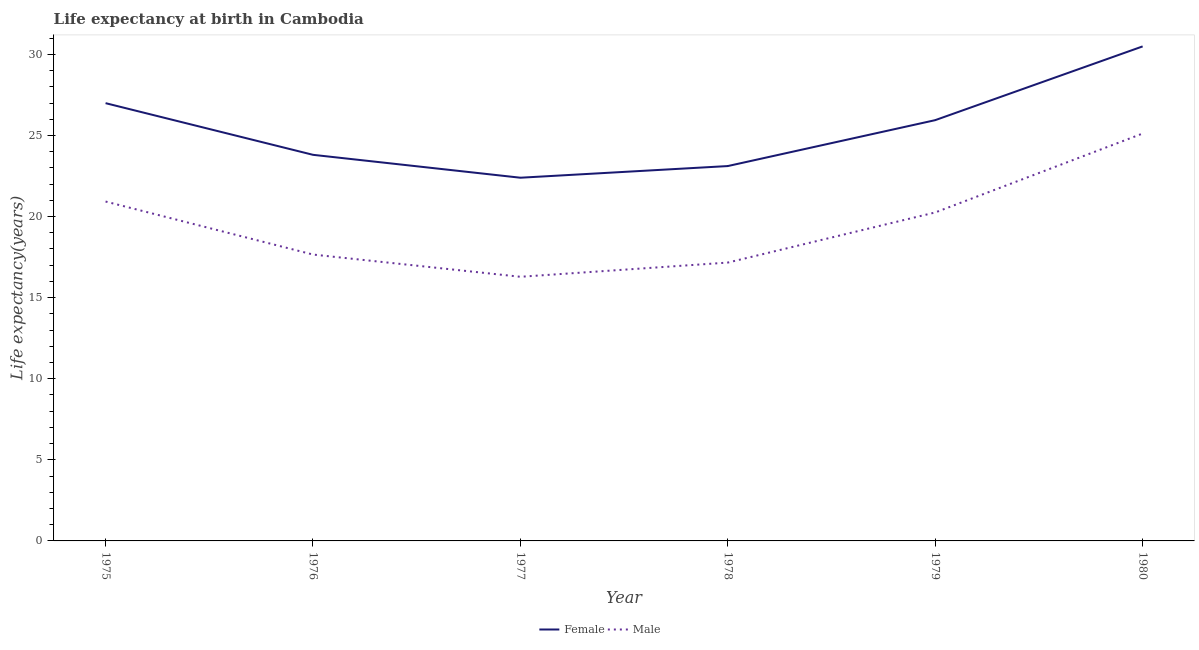What is the life expectancy(male) in 1980?
Provide a short and direct response. 25.12. Across all years, what is the maximum life expectancy(female)?
Offer a terse response. 30.49. Across all years, what is the minimum life expectancy(female)?
Provide a short and direct response. 22.39. In which year was the life expectancy(female) maximum?
Make the answer very short. 1980. In which year was the life expectancy(female) minimum?
Ensure brevity in your answer.  1977. What is the total life expectancy(female) in the graph?
Ensure brevity in your answer.  152.74. What is the difference between the life expectancy(female) in 1975 and that in 1979?
Keep it short and to the point. 1.05. What is the difference between the life expectancy(male) in 1976 and the life expectancy(female) in 1975?
Offer a terse response. -9.33. What is the average life expectancy(female) per year?
Make the answer very short. 25.46. In the year 1980, what is the difference between the life expectancy(female) and life expectancy(male)?
Give a very brief answer. 5.37. In how many years, is the life expectancy(male) greater than 8 years?
Offer a terse response. 6. What is the ratio of the life expectancy(male) in 1978 to that in 1979?
Your answer should be compact. 0.85. Is the life expectancy(male) in 1975 less than that in 1978?
Ensure brevity in your answer.  No. What is the difference between the highest and the second highest life expectancy(male)?
Your answer should be very brief. 4.19. What is the difference between the highest and the lowest life expectancy(male)?
Offer a very short reply. 8.83. In how many years, is the life expectancy(female) greater than the average life expectancy(female) taken over all years?
Provide a short and direct response. 3. Is the sum of the life expectancy(male) in 1976 and 1980 greater than the maximum life expectancy(female) across all years?
Give a very brief answer. Yes. Is the life expectancy(male) strictly greater than the life expectancy(female) over the years?
Offer a very short reply. No. How many years are there in the graph?
Keep it short and to the point. 6. Does the graph contain any zero values?
Your answer should be very brief. No. Does the graph contain grids?
Make the answer very short. No. How are the legend labels stacked?
Make the answer very short. Horizontal. What is the title of the graph?
Provide a succinct answer. Life expectancy at birth in Cambodia. Does "Export" appear as one of the legend labels in the graph?
Your answer should be compact. No. What is the label or title of the X-axis?
Give a very brief answer. Year. What is the label or title of the Y-axis?
Offer a very short reply. Life expectancy(years). What is the Life expectancy(years) of Female in 1975?
Offer a very short reply. 26.99. What is the Life expectancy(years) in Male in 1975?
Make the answer very short. 20.93. What is the Life expectancy(years) of Female in 1976?
Your answer should be very brief. 23.81. What is the Life expectancy(years) in Male in 1976?
Your answer should be compact. 17.66. What is the Life expectancy(years) in Female in 1977?
Your answer should be compact. 22.39. What is the Life expectancy(years) in Male in 1977?
Keep it short and to the point. 16.29. What is the Life expectancy(years) in Female in 1978?
Give a very brief answer. 23.11. What is the Life expectancy(years) in Male in 1978?
Your answer should be very brief. 17.16. What is the Life expectancy(years) in Female in 1979?
Ensure brevity in your answer.  25.94. What is the Life expectancy(years) of Male in 1979?
Give a very brief answer. 20.25. What is the Life expectancy(years) of Female in 1980?
Keep it short and to the point. 30.49. What is the Life expectancy(years) of Male in 1980?
Your answer should be very brief. 25.12. Across all years, what is the maximum Life expectancy(years) in Female?
Give a very brief answer. 30.49. Across all years, what is the maximum Life expectancy(years) of Male?
Ensure brevity in your answer.  25.12. Across all years, what is the minimum Life expectancy(years) of Female?
Provide a succinct answer. 22.39. Across all years, what is the minimum Life expectancy(years) in Male?
Provide a short and direct response. 16.29. What is the total Life expectancy(years) of Female in the graph?
Give a very brief answer. 152.74. What is the total Life expectancy(years) of Male in the graph?
Offer a terse response. 117.4. What is the difference between the Life expectancy(years) in Female in 1975 and that in 1976?
Keep it short and to the point. 3.19. What is the difference between the Life expectancy(years) of Male in 1975 and that in 1976?
Your answer should be compact. 3.27. What is the difference between the Life expectancy(years) of Female in 1975 and that in 1977?
Make the answer very short. 4.6. What is the difference between the Life expectancy(years) in Male in 1975 and that in 1977?
Your answer should be compact. 4.64. What is the difference between the Life expectancy(years) in Female in 1975 and that in 1978?
Provide a succinct answer. 3.88. What is the difference between the Life expectancy(years) in Male in 1975 and that in 1978?
Ensure brevity in your answer.  3.76. What is the difference between the Life expectancy(years) of Female in 1975 and that in 1979?
Offer a terse response. 1.05. What is the difference between the Life expectancy(years) in Male in 1975 and that in 1979?
Offer a terse response. 0.67. What is the difference between the Life expectancy(years) in Female in 1975 and that in 1980?
Your answer should be very brief. -3.5. What is the difference between the Life expectancy(years) of Male in 1975 and that in 1980?
Your answer should be compact. -4.19. What is the difference between the Life expectancy(years) in Female in 1976 and that in 1977?
Offer a terse response. 1.41. What is the difference between the Life expectancy(years) of Male in 1976 and that in 1977?
Your answer should be very brief. 1.37. What is the difference between the Life expectancy(years) of Female in 1976 and that in 1978?
Offer a very short reply. 0.69. What is the difference between the Life expectancy(years) in Male in 1976 and that in 1978?
Your response must be concise. 0.49. What is the difference between the Life expectancy(years) in Female in 1976 and that in 1979?
Give a very brief answer. -2.14. What is the difference between the Life expectancy(years) in Male in 1976 and that in 1979?
Offer a very short reply. -2.6. What is the difference between the Life expectancy(years) in Female in 1976 and that in 1980?
Keep it short and to the point. -6.68. What is the difference between the Life expectancy(years) of Male in 1976 and that in 1980?
Provide a short and direct response. -7.46. What is the difference between the Life expectancy(years) in Female in 1977 and that in 1978?
Your answer should be very brief. -0.72. What is the difference between the Life expectancy(years) of Male in 1977 and that in 1978?
Offer a very short reply. -0.88. What is the difference between the Life expectancy(years) in Female in 1977 and that in 1979?
Offer a very short reply. -3.55. What is the difference between the Life expectancy(years) of Male in 1977 and that in 1979?
Your response must be concise. -3.97. What is the difference between the Life expectancy(years) of Female in 1977 and that in 1980?
Make the answer very short. -8.1. What is the difference between the Life expectancy(years) in Male in 1977 and that in 1980?
Your answer should be compact. -8.83. What is the difference between the Life expectancy(years) in Female in 1978 and that in 1979?
Give a very brief answer. -2.83. What is the difference between the Life expectancy(years) of Male in 1978 and that in 1979?
Offer a very short reply. -3.09. What is the difference between the Life expectancy(years) in Female in 1978 and that in 1980?
Ensure brevity in your answer.  -7.38. What is the difference between the Life expectancy(years) of Male in 1978 and that in 1980?
Make the answer very short. -7.96. What is the difference between the Life expectancy(years) of Female in 1979 and that in 1980?
Ensure brevity in your answer.  -4.55. What is the difference between the Life expectancy(years) of Male in 1979 and that in 1980?
Make the answer very short. -4.87. What is the difference between the Life expectancy(years) of Female in 1975 and the Life expectancy(years) of Male in 1976?
Give a very brief answer. 9.33. What is the difference between the Life expectancy(years) in Female in 1975 and the Life expectancy(years) in Male in 1977?
Provide a succinct answer. 10.71. What is the difference between the Life expectancy(years) of Female in 1975 and the Life expectancy(years) of Male in 1978?
Keep it short and to the point. 9.83. What is the difference between the Life expectancy(years) of Female in 1975 and the Life expectancy(years) of Male in 1979?
Make the answer very short. 6.74. What is the difference between the Life expectancy(years) in Female in 1975 and the Life expectancy(years) in Male in 1980?
Provide a short and direct response. 1.87. What is the difference between the Life expectancy(years) of Female in 1976 and the Life expectancy(years) of Male in 1977?
Make the answer very short. 7.52. What is the difference between the Life expectancy(years) in Female in 1976 and the Life expectancy(years) in Male in 1978?
Offer a very short reply. 6.64. What is the difference between the Life expectancy(years) in Female in 1976 and the Life expectancy(years) in Male in 1979?
Your answer should be compact. 3.55. What is the difference between the Life expectancy(years) in Female in 1976 and the Life expectancy(years) in Male in 1980?
Offer a very short reply. -1.31. What is the difference between the Life expectancy(years) in Female in 1977 and the Life expectancy(years) in Male in 1978?
Offer a terse response. 5.23. What is the difference between the Life expectancy(years) in Female in 1977 and the Life expectancy(years) in Male in 1979?
Make the answer very short. 2.14. What is the difference between the Life expectancy(years) in Female in 1977 and the Life expectancy(years) in Male in 1980?
Give a very brief answer. -2.72. What is the difference between the Life expectancy(years) of Female in 1978 and the Life expectancy(years) of Male in 1979?
Provide a succinct answer. 2.86. What is the difference between the Life expectancy(years) of Female in 1978 and the Life expectancy(years) of Male in 1980?
Your answer should be compact. -2. What is the difference between the Life expectancy(years) of Female in 1979 and the Life expectancy(years) of Male in 1980?
Offer a very short reply. 0.83. What is the average Life expectancy(years) in Female per year?
Keep it short and to the point. 25.46. What is the average Life expectancy(years) of Male per year?
Make the answer very short. 19.57. In the year 1975, what is the difference between the Life expectancy(years) in Female and Life expectancy(years) in Male?
Offer a very short reply. 6.07. In the year 1976, what is the difference between the Life expectancy(years) of Female and Life expectancy(years) of Male?
Keep it short and to the point. 6.15. In the year 1977, what is the difference between the Life expectancy(years) of Female and Life expectancy(years) of Male?
Provide a short and direct response. 6.11. In the year 1978, what is the difference between the Life expectancy(years) of Female and Life expectancy(years) of Male?
Your answer should be compact. 5.95. In the year 1979, what is the difference between the Life expectancy(years) of Female and Life expectancy(years) of Male?
Your answer should be compact. 5.69. In the year 1980, what is the difference between the Life expectancy(years) in Female and Life expectancy(years) in Male?
Make the answer very short. 5.37. What is the ratio of the Life expectancy(years) of Female in 1975 to that in 1976?
Your response must be concise. 1.13. What is the ratio of the Life expectancy(years) in Male in 1975 to that in 1976?
Offer a very short reply. 1.19. What is the ratio of the Life expectancy(years) of Female in 1975 to that in 1977?
Your response must be concise. 1.21. What is the ratio of the Life expectancy(years) in Male in 1975 to that in 1977?
Provide a succinct answer. 1.28. What is the ratio of the Life expectancy(years) of Female in 1975 to that in 1978?
Provide a succinct answer. 1.17. What is the ratio of the Life expectancy(years) of Male in 1975 to that in 1978?
Offer a very short reply. 1.22. What is the ratio of the Life expectancy(years) of Female in 1975 to that in 1979?
Make the answer very short. 1.04. What is the ratio of the Life expectancy(years) of Male in 1975 to that in 1979?
Provide a short and direct response. 1.03. What is the ratio of the Life expectancy(years) in Female in 1975 to that in 1980?
Your answer should be very brief. 0.89. What is the ratio of the Life expectancy(years) in Male in 1975 to that in 1980?
Your answer should be very brief. 0.83. What is the ratio of the Life expectancy(years) in Female in 1976 to that in 1977?
Provide a succinct answer. 1.06. What is the ratio of the Life expectancy(years) of Male in 1976 to that in 1977?
Give a very brief answer. 1.08. What is the ratio of the Life expectancy(years) of Male in 1976 to that in 1978?
Make the answer very short. 1.03. What is the ratio of the Life expectancy(years) in Female in 1976 to that in 1979?
Keep it short and to the point. 0.92. What is the ratio of the Life expectancy(years) of Male in 1976 to that in 1979?
Provide a succinct answer. 0.87. What is the ratio of the Life expectancy(years) in Female in 1976 to that in 1980?
Your answer should be compact. 0.78. What is the ratio of the Life expectancy(years) in Male in 1976 to that in 1980?
Offer a terse response. 0.7. What is the ratio of the Life expectancy(years) in Female in 1977 to that in 1978?
Ensure brevity in your answer.  0.97. What is the ratio of the Life expectancy(years) in Male in 1977 to that in 1978?
Your answer should be compact. 0.95. What is the ratio of the Life expectancy(years) in Female in 1977 to that in 1979?
Provide a short and direct response. 0.86. What is the ratio of the Life expectancy(years) in Male in 1977 to that in 1979?
Ensure brevity in your answer.  0.8. What is the ratio of the Life expectancy(years) of Female in 1977 to that in 1980?
Make the answer very short. 0.73. What is the ratio of the Life expectancy(years) of Male in 1977 to that in 1980?
Your answer should be compact. 0.65. What is the ratio of the Life expectancy(years) in Female in 1978 to that in 1979?
Provide a short and direct response. 0.89. What is the ratio of the Life expectancy(years) of Male in 1978 to that in 1979?
Provide a succinct answer. 0.85. What is the ratio of the Life expectancy(years) of Female in 1978 to that in 1980?
Make the answer very short. 0.76. What is the ratio of the Life expectancy(years) of Male in 1978 to that in 1980?
Offer a very short reply. 0.68. What is the ratio of the Life expectancy(years) in Female in 1979 to that in 1980?
Make the answer very short. 0.85. What is the ratio of the Life expectancy(years) of Male in 1979 to that in 1980?
Offer a terse response. 0.81. What is the difference between the highest and the second highest Life expectancy(years) in Male?
Offer a very short reply. 4.19. What is the difference between the highest and the lowest Life expectancy(years) in Female?
Make the answer very short. 8.1. What is the difference between the highest and the lowest Life expectancy(years) of Male?
Ensure brevity in your answer.  8.83. 